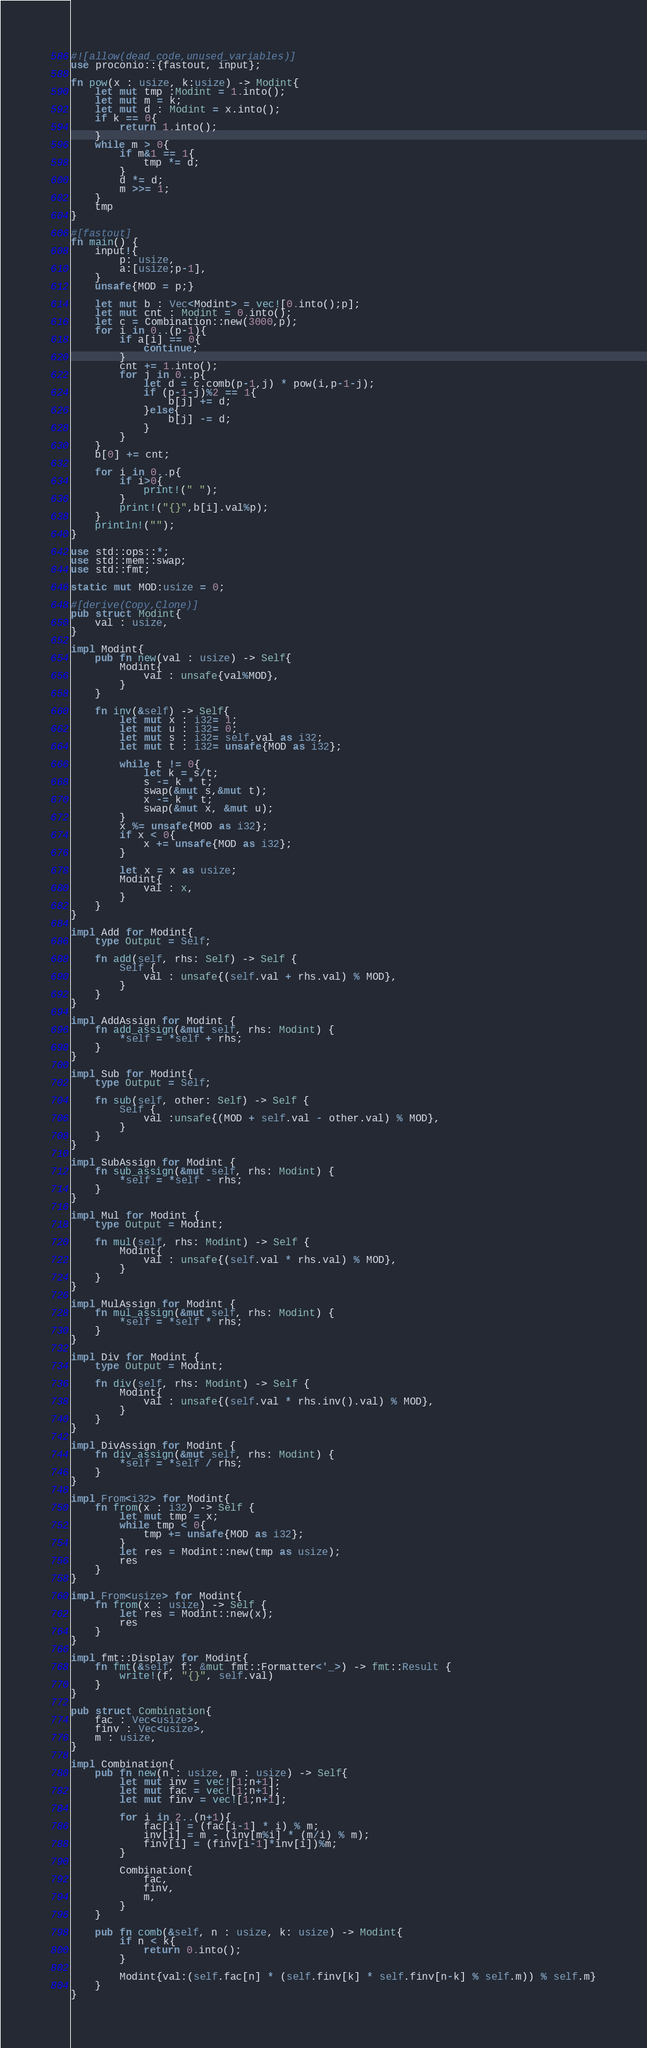Convert code to text. <code><loc_0><loc_0><loc_500><loc_500><_Rust_>#![allow(dead_code,unused_variables)]
use proconio::{fastout, input};

fn pow(x : usize, k:usize) -> Modint{
    let mut tmp :Modint = 1.into();
    let mut m = k;
    let mut d : Modint = x.into();
    if k == 0{
        return 1.into();
    }
    while m > 0{
        if m&1 == 1{
            tmp *= d;
        }
        d *= d;
        m >>= 1;
    }
    tmp
}

#[fastout]
fn main() {
    input!{
        p: usize,
        a:[usize;p-1],
    }
    unsafe{MOD = p;}

    let mut b : Vec<Modint> = vec![0.into();p];
    let mut cnt : Modint = 0.into();
    let c = Combination::new(3000,p);
    for i in 0..(p-1){
        if a[i] == 0{
            continue;
        }
        cnt += 1.into();
        for j in 0..p{
            let d = c.comb(p-1,j) * pow(i,p-1-j);
            if (p-1-j)%2 == 1{
                b[j] += d;
            }else{
                b[j] -= d;
            }
        }
    }
    b[0] += cnt;

    for i in 0..p{
        if i>0{
            print!(" ");
        }
        print!("{}",b[i].val%p);
    }
    println!("");
}

use std::ops::*;
use std::mem::swap;
use std::fmt;

static mut MOD:usize = 0;

#[derive(Copy,Clone)]
pub struct Modint{
    val : usize,
}

impl Modint{
    pub fn new(val : usize) -> Self{
        Modint{
            val : unsafe{val%MOD},
        }
    }

    fn inv(&self) -> Self{
        let mut x : i32= 1;
        let mut u : i32= 0;
        let mut s : i32= self.val as i32;
        let mut t : i32= unsafe{MOD as i32};

        while t != 0{
            let k = s/t;
            s -= k * t;
            swap(&mut s,&mut t);
            x -= k * t;
            swap(&mut x, &mut u);
        }
        x %= unsafe{MOD as i32};
        if x < 0{
            x += unsafe{MOD as i32};
        }
        
        let x = x as usize;
        Modint{
            val : x,
        }
    }
}

impl Add for Modint{
    type Output = Self;

    fn add(self, rhs: Self) -> Self {
        Self {
            val : unsafe{(self.val + rhs.val) % MOD},
        }
    }
}

impl AddAssign for Modint {
    fn add_assign(&mut self, rhs: Modint) {
        *self = *self + rhs;
    }
}

impl Sub for Modint{
    type Output = Self;

    fn sub(self, other: Self) -> Self {
        Self {
            val :unsafe{(MOD + self.val - other.val) % MOD},
        }
    }
}

impl SubAssign for Modint {
    fn sub_assign(&mut self, rhs: Modint) {
        *self = *self - rhs;
    }
}

impl Mul for Modint {
    type Output = Modint;

    fn mul(self, rhs: Modint) -> Self {
        Modint{
            val : unsafe{(self.val * rhs.val) % MOD},
        }
    }
}

impl MulAssign for Modint {
    fn mul_assign(&mut self, rhs: Modint) {
        *self = *self * rhs;
    }
}

impl Div for Modint {
    type Output = Modint;

    fn div(self, rhs: Modint) -> Self {
        Modint{
            val : unsafe{(self.val * rhs.inv().val) % MOD},
        }
    }
}

impl DivAssign for Modint {
    fn div_assign(&mut self, rhs: Modint) {
        *self = *self / rhs;
    }
}

impl From<i32> for Modint{
    fn from(x : i32) -> Self {
        let mut tmp = x;
        while tmp < 0{
            tmp += unsafe{MOD as i32};
        }
        let res = Modint::new(tmp as usize);
        res
    }
}

impl From<usize> for Modint{
    fn from(x : usize) -> Self {
        let res = Modint::new(x);
        res
    }
}

impl fmt::Display for Modint{
    fn fmt(&self, f: &mut fmt::Formatter<'_>) -> fmt::Result {
        write!(f, "{}", self.val)
    }
}

pub struct Combination{
    fac : Vec<usize>,
    finv : Vec<usize>,
    m : usize,
}

impl Combination{
    pub fn new(n : usize, m : usize) -> Self{
        let mut inv = vec![1;n+1];
        let mut fac = vec![1;n+1];
        let mut finv = vec![1;n+1];

        for i in 2..(n+1){
            fac[i] = (fac[i-1] * i) % m;
            inv[i] = m - (inv[m%i] * (m/i) % m);
            finv[i] = (finv[i-1]*inv[i])%m;
        }

        Combination{
            fac,
            finv,
            m,
        }
    }

    pub fn comb(&self, n : usize, k: usize) -> Modint{
        if n < k{
            return 0.into();
        }

        Modint{val:(self.fac[n] * (self.finv[k] * self.finv[n-k] % self.m)) % self.m}
    }
}</code> 